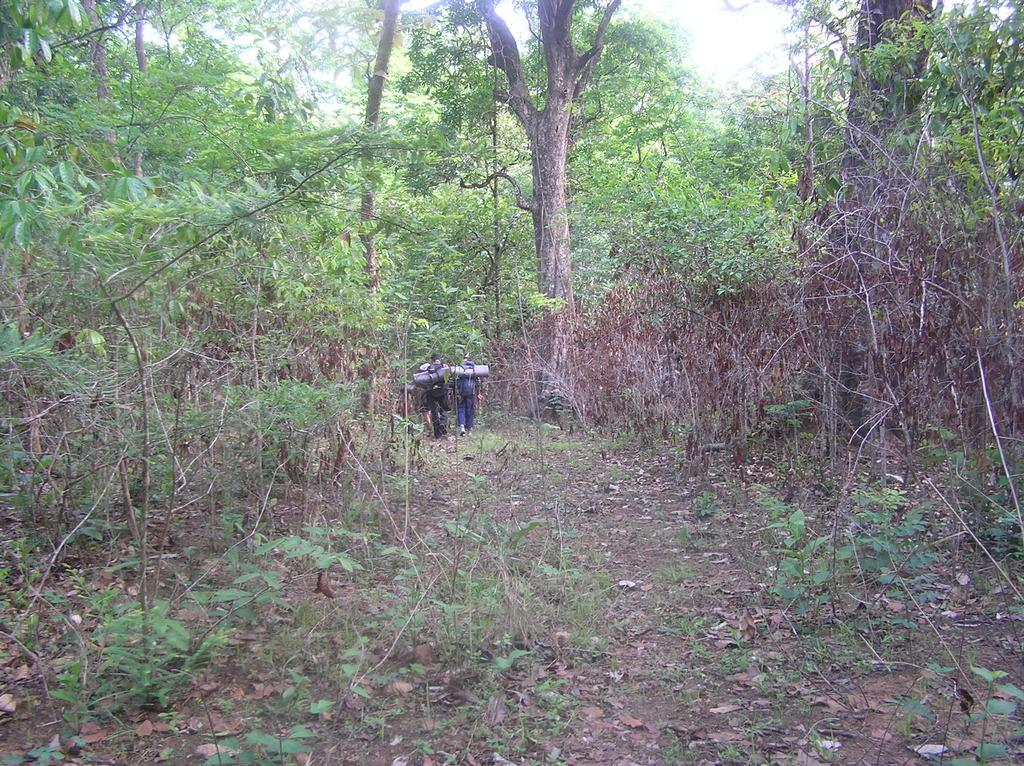How many people are in the image? There are two people in the center of the image. What are the people wearing? The people are wearing bags. What can be seen in the background of the image? There is greenery around the area of the image, and it appears to be in the woods. What type of flowers can be seen on the people's faces in the image? There are no flowers visible on the people's faces in the image. 